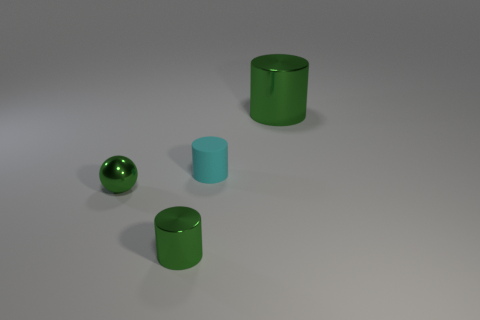The other green cylinder that is the same material as the small green cylinder is what size?
Provide a short and direct response. Large. Are there any other things of the same color as the large object?
Your answer should be compact. Yes. The green thing to the left of the metal cylinder that is to the left of the green object that is on the right side of the cyan cylinder is made of what material?
Provide a succinct answer. Metal. What number of matte things are tiny cylinders or cyan cylinders?
Provide a succinct answer. 1. Does the ball have the same color as the large metallic object?
Offer a very short reply. Yes. Are there any other things that are made of the same material as the cyan object?
Offer a terse response. No. How many things are tiny balls or metallic things that are behind the tiny green ball?
Offer a terse response. 2. Does the green shiny cylinder that is in front of the matte thing have the same size as the small rubber object?
Make the answer very short. Yes. What number of other things are the same shape as the tiny cyan thing?
Offer a terse response. 2. How many brown things are either metal cylinders or tiny spheres?
Your response must be concise. 0. 